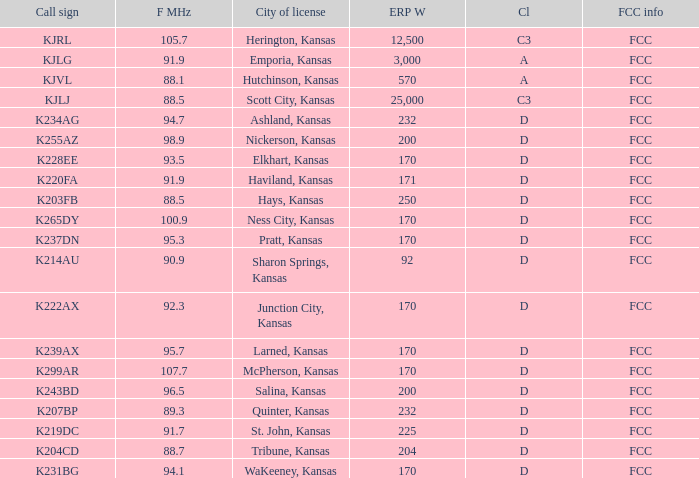Class of d, and a Frequency MHz smaller than 107.7, and a ERP W smaller than 232 has what call sign? K255AZ, K228EE, K220FA, K265DY, K237DN, K214AU, K222AX, K239AX, K243BD, K219DC, K204CD, K231BG. 